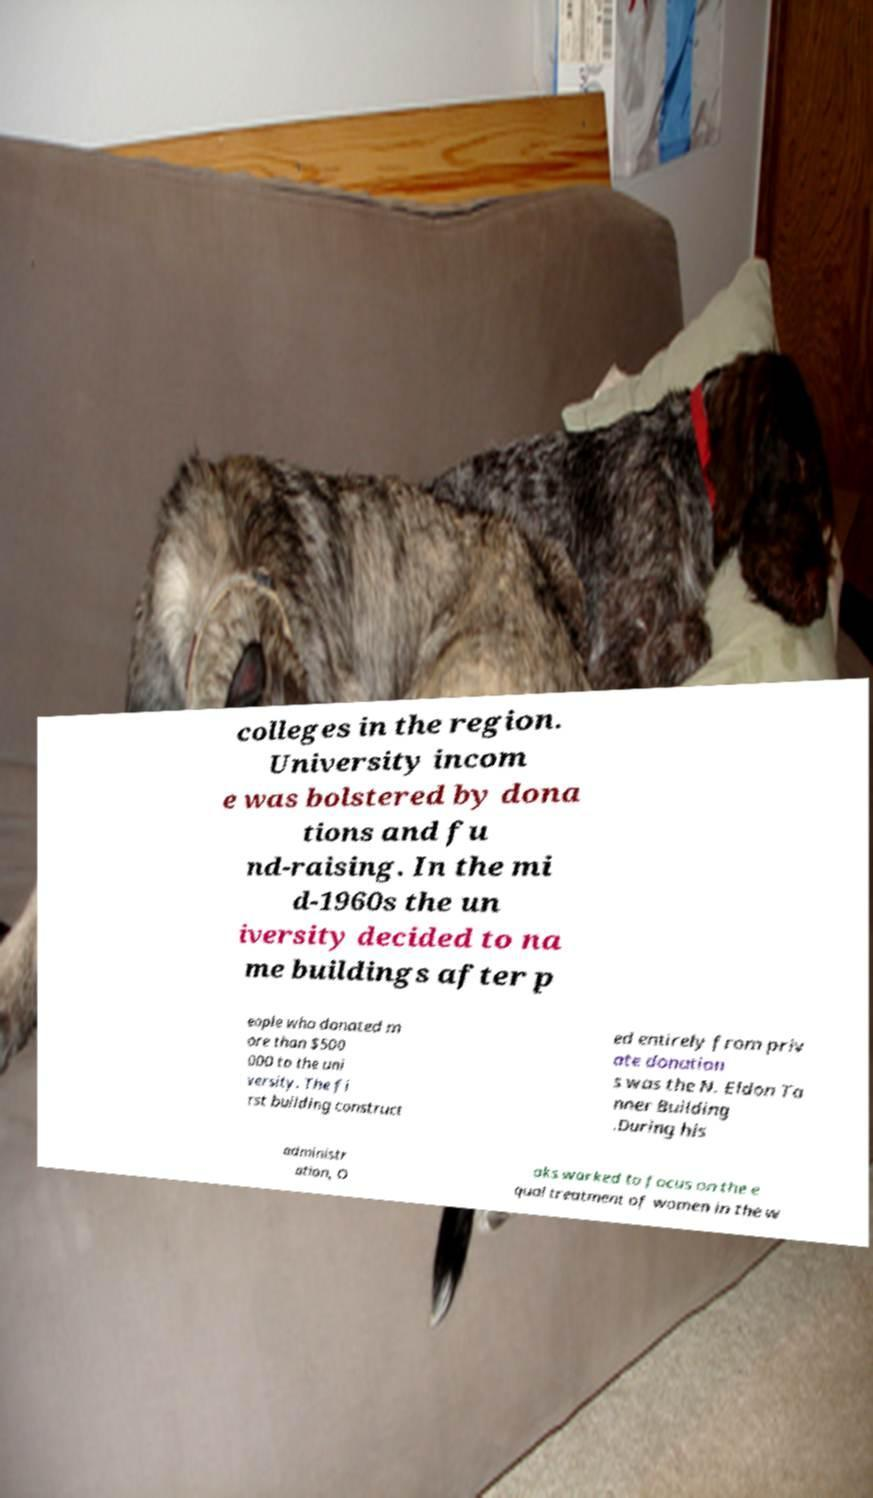I need the written content from this picture converted into text. Can you do that? colleges in the region. University incom e was bolstered by dona tions and fu nd-raising. In the mi d-1960s the un iversity decided to na me buildings after p eople who donated m ore than $500 000 to the uni versity. The fi rst building construct ed entirely from priv ate donation s was the N. Eldon Ta nner Building .During his administr ation, O aks worked to focus on the e qual treatment of women in the w 